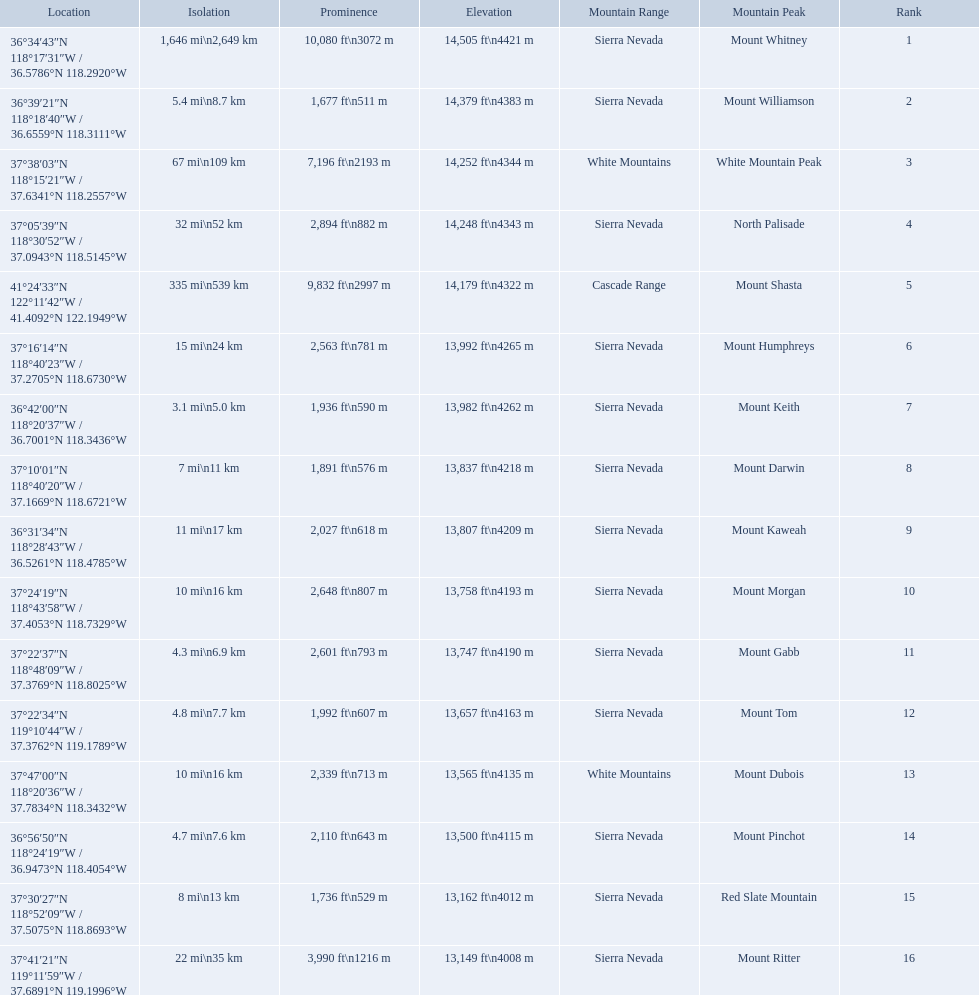What are all of the mountain peaks? Mount Whitney, Mount Williamson, White Mountain Peak, North Palisade, Mount Shasta, Mount Humphreys, Mount Keith, Mount Darwin, Mount Kaweah, Mount Morgan, Mount Gabb, Mount Tom, Mount Dubois, Mount Pinchot, Red Slate Mountain, Mount Ritter. In what ranges are they located? Sierra Nevada, Sierra Nevada, White Mountains, Sierra Nevada, Cascade Range, Sierra Nevada, Sierra Nevada, Sierra Nevada, Sierra Nevada, Sierra Nevada, Sierra Nevada, Sierra Nevada, White Mountains, Sierra Nevada, Sierra Nevada, Sierra Nevada. And which mountain peak is in the cascade range? Mount Shasta. 